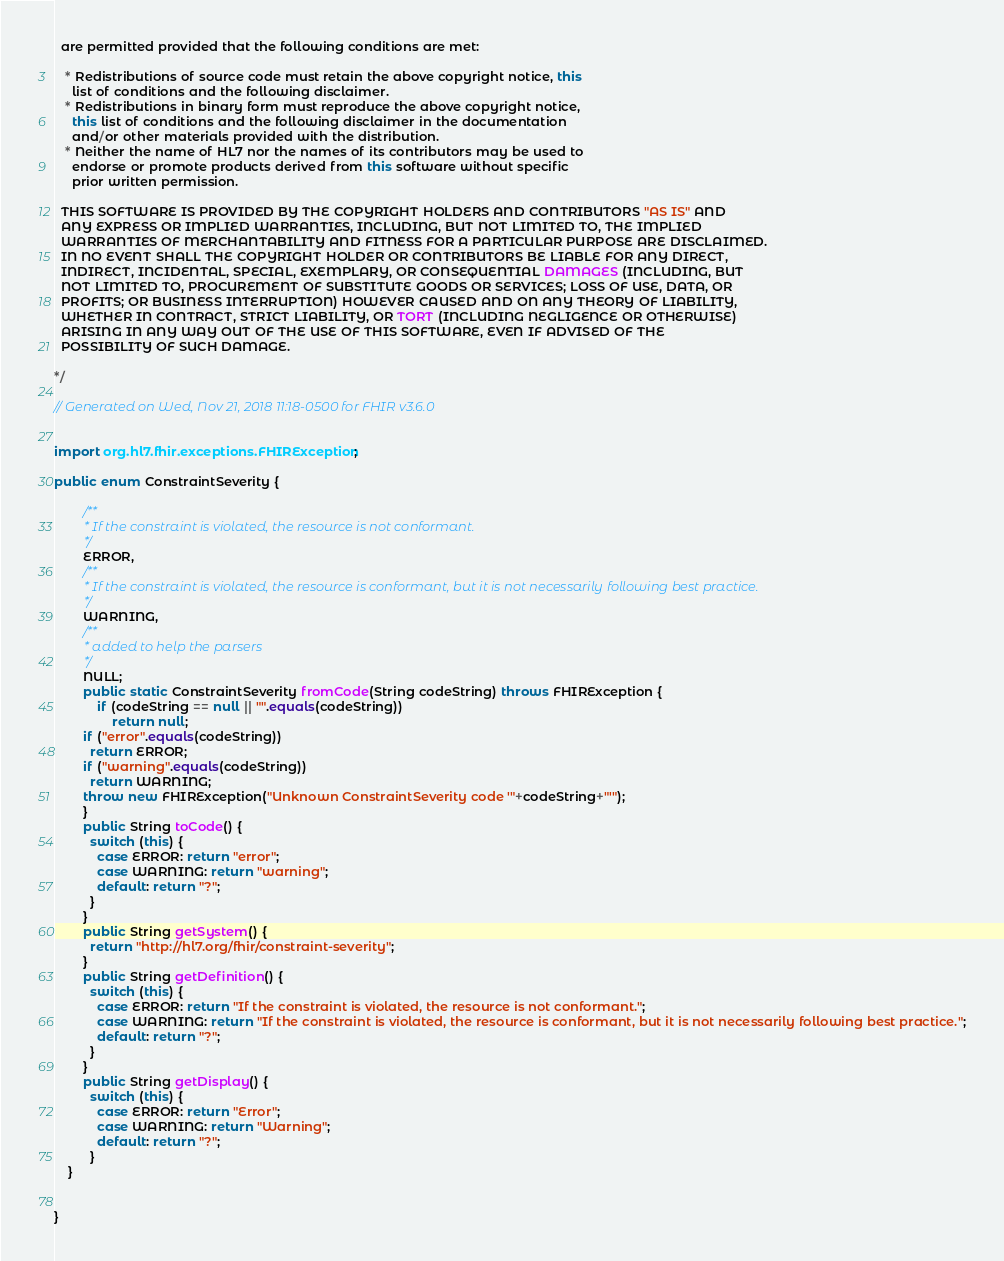Convert code to text. <code><loc_0><loc_0><loc_500><loc_500><_Java_>  are permitted provided that the following conditions are met:
  
   * Redistributions of source code must retain the above copyright notice, this 
     list of conditions and the following disclaimer.
   * Redistributions in binary form must reproduce the above copyright notice, 
     this list of conditions and the following disclaimer in the documentation 
     and/or other materials provided with the distribution.
   * Neither the name of HL7 nor the names of its contributors may be used to 
     endorse or promote products derived from this software without specific 
     prior written permission.
  
  THIS SOFTWARE IS PROVIDED BY THE COPYRIGHT HOLDERS AND CONTRIBUTORS "AS IS" AND 
  ANY EXPRESS OR IMPLIED WARRANTIES, INCLUDING, BUT NOT LIMITED TO, THE IMPLIED 
  WARRANTIES OF MERCHANTABILITY AND FITNESS FOR A PARTICULAR PURPOSE ARE DISCLAIMED. 
  IN NO EVENT SHALL THE COPYRIGHT HOLDER OR CONTRIBUTORS BE LIABLE FOR ANY DIRECT, 
  INDIRECT, INCIDENTAL, SPECIAL, EXEMPLARY, OR CONSEQUENTIAL DAMAGES (INCLUDING, BUT 
  NOT LIMITED TO, PROCUREMENT OF SUBSTITUTE GOODS OR SERVICES; LOSS OF USE, DATA, OR 
  PROFITS; OR BUSINESS INTERRUPTION) HOWEVER CAUSED AND ON ANY THEORY OF LIABILITY, 
  WHETHER IN CONTRACT, STRICT LIABILITY, OR TORT (INCLUDING NEGLIGENCE OR OTHERWISE) 
  ARISING IN ANY WAY OUT OF THE USE OF THIS SOFTWARE, EVEN IF ADVISED OF THE 
  POSSIBILITY OF SUCH DAMAGE.
  
*/

// Generated on Wed, Nov 21, 2018 11:18-0500 for FHIR v3.6.0


import org.hl7.fhir.exceptions.FHIRException;

public enum ConstraintSeverity {

        /**
         * If the constraint is violated, the resource is not conformant.
         */
        ERROR, 
        /**
         * If the constraint is violated, the resource is conformant, but it is not necessarily following best practice.
         */
        WARNING, 
        /**
         * added to help the parsers
         */
        NULL;
        public static ConstraintSeverity fromCode(String codeString) throws FHIRException {
            if (codeString == null || "".equals(codeString))
                return null;
        if ("error".equals(codeString))
          return ERROR;
        if ("warning".equals(codeString))
          return WARNING;
        throw new FHIRException("Unknown ConstraintSeverity code '"+codeString+"'");
        }
        public String toCode() {
          switch (this) {
            case ERROR: return "error";
            case WARNING: return "warning";
            default: return "?";
          }
        }
        public String getSystem() {
          return "http://hl7.org/fhir/constraint-severity";
        }
        public String getDefinition() {
          switch (this) {
            case ERROR: return "If the constraint is violated, the resource is not conformant.";
            case WARNING: return "If the constraint is violated, the resource is conformant, but it is not necessarily following best practice.";
            default: return "?";
          }
        }
        public String getDisplay() {
          switch (this) {
            case ERROR: return "Error";
            case WARNING: return "Warning";
            default: return "?";
          }
    }


}

</code> 